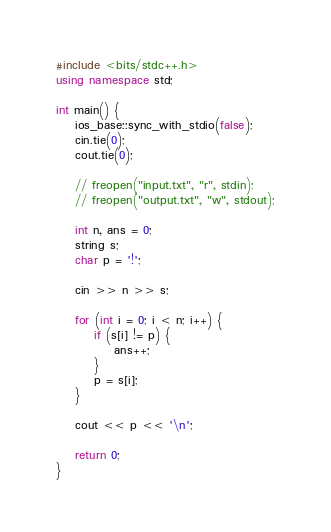<code> <loc_0><loc_0><loc_500><loc_500><_C++_>#include <bits/stdc++.h>
using namespace std;

int main() {
    ios_base::sync_with_stdio(false);
    cin.tie(0);
    cout.tie(0);
 
    // freopen("input.txt", "r", stdin);
    // freopen("output.txt", "w", stdout);
    
    int n, ans = 0;
    string s;
    char p = '!';

    cin >> n >> s;

    for (int i = 0; i < n; i++) {
        if (s[i] != p) {
            ans++;
        }
        p = s[i];
    }

    cout << p << '\n';
 
    return 0;
}</code> 